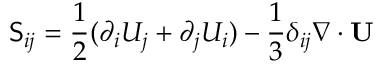<formula> <loc_0><loc_0><loc_500><loc_500>S _ { i j } = \frac { 1 } { 2 } ( \partial _ { i } U _ { j } + \partial _ { j } U _ { i } ) - \frac { 1 } { 3 } \delta _ { i j } \nabla \cdot U</formula> 